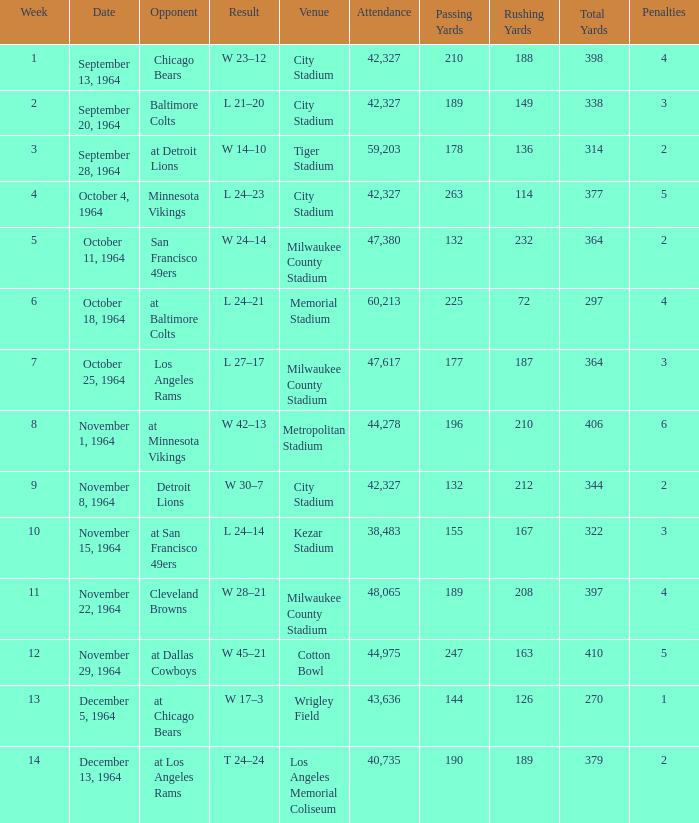For the game held on november 22, 1964, with 48,065 spectators, which average week was it? None. 